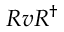<formula> <loc_0><loc_0><loc_500><loc_500>R v R ^ { \dagger }</formula> 